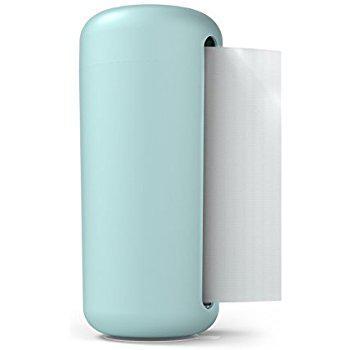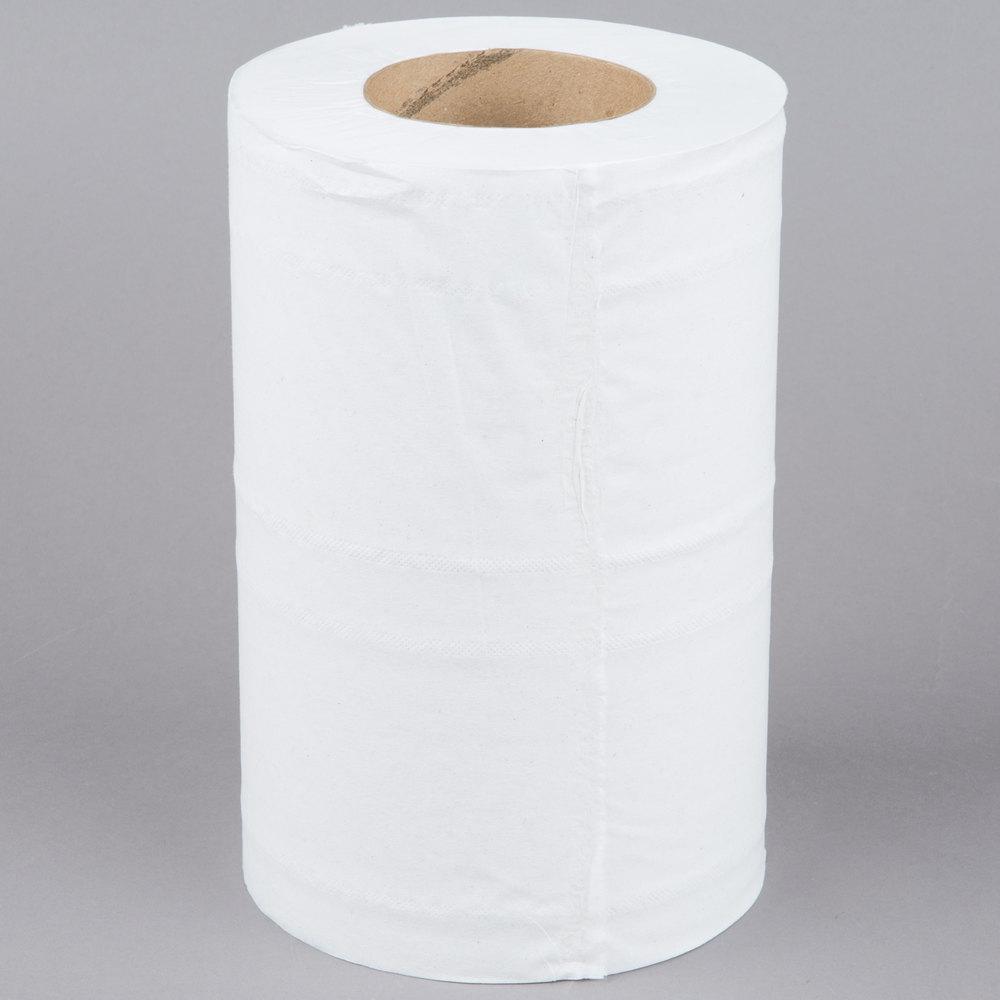The first image is the image on the left, the second image is the image on the right. Analyze the images presented: Is the assertion "One of the images show some type of paper towel dispenser." valid? Answer yes or no. Yes. The first image is the image on the left, the second image is the image on the right. For the images displayed, is the sentence "An image shows a roll of towels on an upright stand with a chrome part that extends out of the top." factually correct? Answer yes or no. No. 